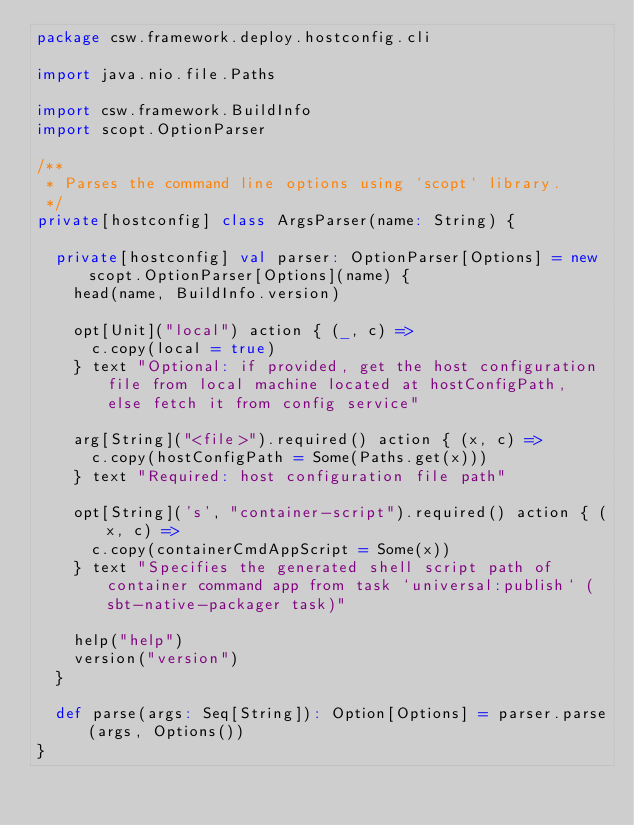<code> <loc_0><loc_0><loc_500><loc_500><_Scala_>package csw.framework.deploy.hostconfig.cli

import java.nio.file.Paths

import csw.framework.BuildInfo
import scopt.OptionParser

/**
 * Parses the command line options using `scopt` library.
 */
private[hostconfig] class ArgsParser(name: String) {

  private[hostconfig] val parser: OptionParser[Options] = new scopt.OptionParser[Options](name) {
    head(name, BuildInfo.version)

    opt[Unit]("local") action { (_, c) =>
      c.copy(local = true)
    } text "Optional: if provided, get the host configuration file from local machine located at hostConfigPath, else fetch it from config service"

    arg[String]("<file>").required() action { (x, c) =>
      c.copy(hostConfigPath = Some(Paths.get(x)))
    } text "Required: host configuration file path"

    opt[String]('s', "container-script").required() action { (x, c) =>
      c.copy(containerCmdAppScript = Some(x))
    } text "Specifies the generated shell script path of container command app from task `universal:publish` (sbt-native-packager task)"

    help("help")
    version("version")
  }

  def parse(args: Seq[String]): Option[Options] = parser.parse(args, Options())
}
</code> 